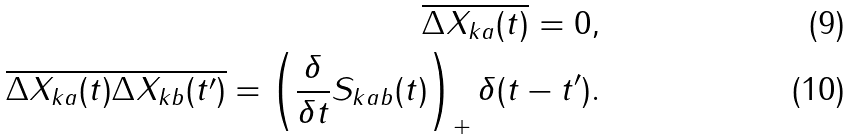<formula> <loc_0><loc_0><loc_500><loc_500>\overline { \Delta X _ { k a } ( t ) } = 0 , \\ \overline { \Delta X _ { k a } ( t ) \Delta X _ { k b } ( t ^ { \prime } ) } = \left ( \frac { \delta } { \delta t } S _ { k a b } ( t ) \right ) _ { + } \delta ( t - t ^ { \prime } ) .</formula> 